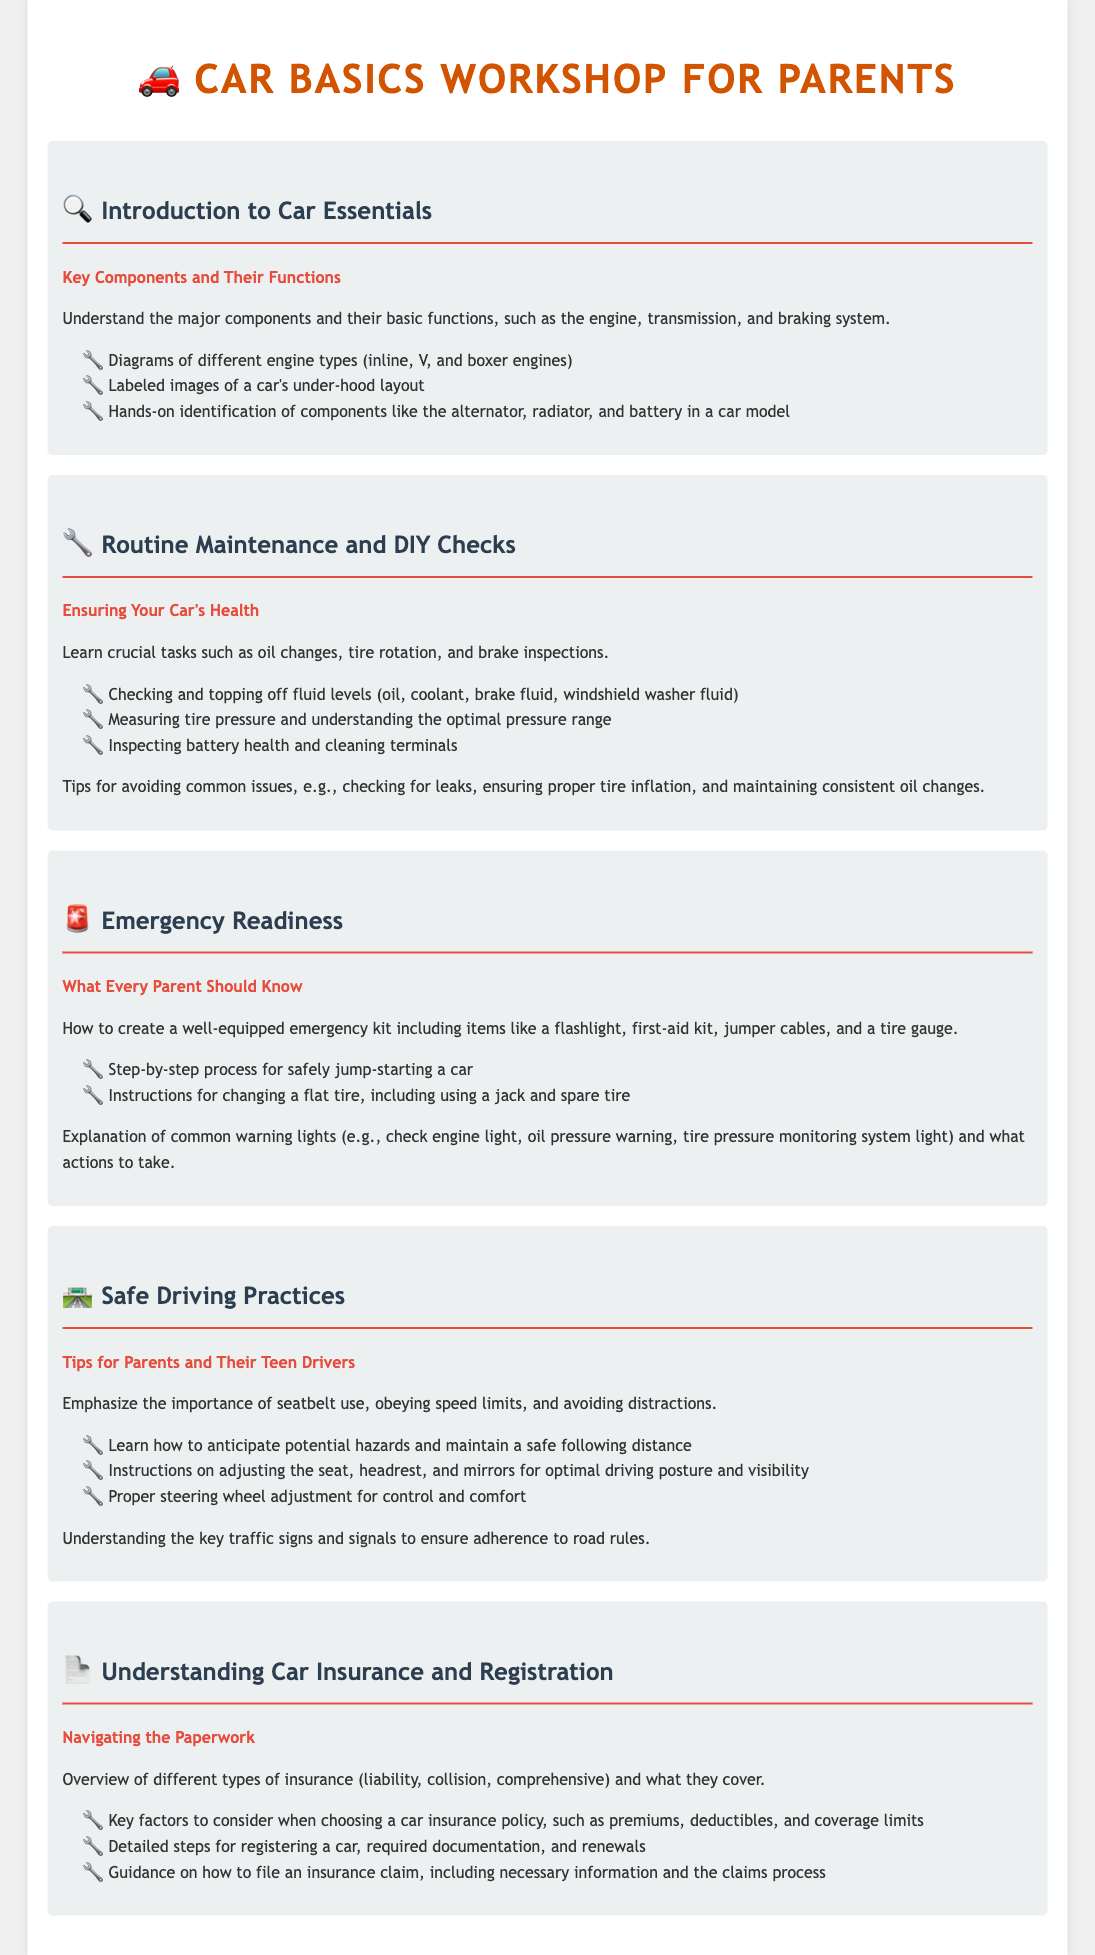What is the title of the workshop? The title provided in the document is prominently displayed at the top.
Answer: Car Basics Workshop for Parents What component of the car is discussed in the Introduction module? The introduction covers major components such as the engine, transmission, and braking system.
Answer: Engine What does the Routine Maintenance module emphasize? This module focuses on essential maintenance tasks that are crucial for the car's upkeep.
Answer: Essential maintenance tasks How many engine types are illustrated in the Introduction module? The document mentions diagrams for three types of engines in the introduction.
Answer: Three What is included in the Emergency Readiness section? This section includes instructions on how to create an emergency kit and handle roadside emergencies.
Answer: Emergency kit Which driving habit is emphasized in the Safe Driving Practices module? The document highlights the importance of seatbelt use as a critical driving habit.
Answer: Seatbelt use What type of insurance is explained in the Understanding Car Insurance module? The syllabus provides an overview of multiple types of car insurance.
Answer: Types of car insurance What is one of the steps outlined for changing a flat tire? The document specifies the use of a jack as part of the flat tire changing procedure.
Answer: Using a jack Which safety practice does the Safe Driving Practices module address? This module discusses the importance of maintaining a safe following distance while driving.
Answer: Safe following distance 